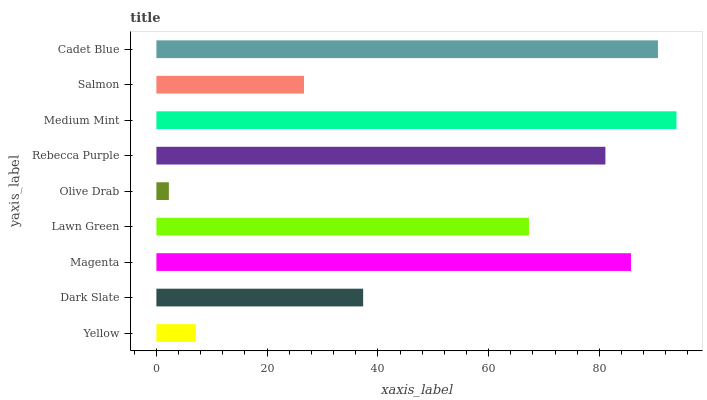Is Olive Drab the minimum?
Answer yes or no. Yes. Is Medium Mint the maximum?
Answer yes or no. Yes. Is Dark Slate the minimum?
Answer yes or no. No. Is Dark Slate the maximum?
Answer yes or no. No. Is Dark Slate greater than Yellow?
Answer yes or no. Yes. Is Yellow less than Dark Slate?
Answer yes or no. Yes. Is Yellow greater than Dark Slate?
Answer yes or no. No. Is Dark Slate less than Yellow?
Answer yes or no. No. Is Lawn Green the high median?
Answer yes or no. Yes. Is Lawn Green the low median?
Answer yes or no. Yes. Is Olive Drab the high median?
Answer yes or no. No. Is Olive Drab the low median?
Answer yes or no. No. 